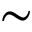<formula> <loc_0><loc_0><loc_500><loc_500>\sim</formula> 